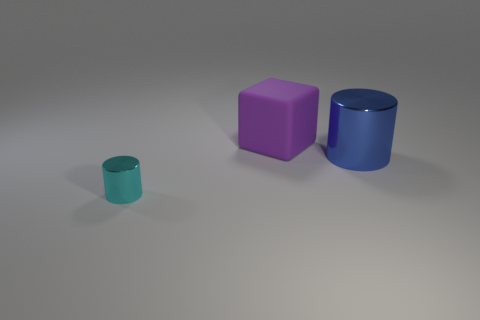Subtract all cubes. How many objects are left? 2 Add 1 purple objects. How many purple objects are left? 2 Add 1 purple spheres. How many purple spheres exist? 1 Add 3 large purple matte things. How many objects exist? 6 Subtract 1 blue cylinders. How many objects are left? 2 Subtract 1 blocks. How many blocks are left? 0 Subtract all blue cylinders. Subtract all purple balls. How many cylinders are left? 1 Subtract all yellow balls. How many cyan cylinders are left? 1 Subtract all blue metallic things. Subtract all big cubes. How many objects are left? 1 